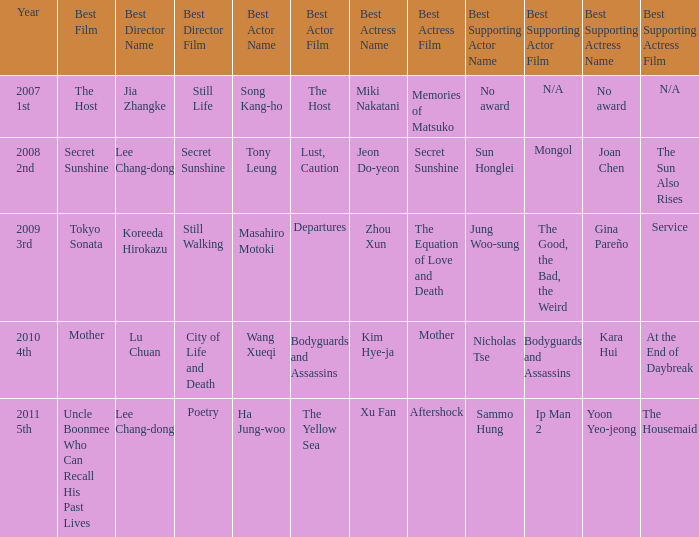Could you help me parse every detail presented in this table? {'header': ['Year', 'Best Film', 'Best Director Name', 'Best Director Film', 'Best Actor Name', 'Best Actor Film', 'Best Actress Name', 'Best Actress Film', 'Best Supporting Actor Name', 'Best Supporting Actor Film', 'Best Supporting Actress Name', 'Best Supporting Actress Film'], 'rows': [['2007 1st', 'The Host', 'Jia Zhangke', 'Still Life', 'Song Kang-ho', 'The Host', 'Miki Nakatani', 'Memories of Matsuko', 'No award', 'N/A', 'No award', 'N/A'], ['2008 2nd', 'Secret Sunshine', 'Lee Chang-dong', 'Secret Sunshine', 'Tony Leung', 'Lust, Caution', 'Jeon Do-yeon', 'Secret Sunshine', 'Sun Honglei', 'Mongol', 'Joan Chen', 'The Sun Also Rises'], ['2009 3rd', 'Tokyo Sonata', 'Koreeda Hirokazu', 'Still Walking', 'Masahiro Motoki', 'Departures', 'Zhou Xun', 'The Equation of Love and Death', 'Jung Woo-sung', 'The Good, the Bad, the Weird', 'Gina Pareño', 'Service'], ['2010 4th', 'Mother', 'Lu Chuan', 'City of Life and Death', 'Wang Xueqi', 'Bodyguards and Assassins', 'Kim Hye-ja', 'Mother', 'Nicholas Tse', 'Bodyguards and Assassins', 'Kara Hui', 'At the End of Daybreak'], ['2011 5th', 'Uncle Boonmee Who Can Recall His Past Lives', 'Lee Chang-dong', 'Poetry', 'Ha Jung-woo', 'The Yellow Sea', 'Xu Fan', 'Aftershock', 'Sammo Hung', 'Ip Man 2', 'Yoon Yeo-jeong', 'The Housemaid']]} Name the best director for mother Lu Chuan for City of Life and Death. 